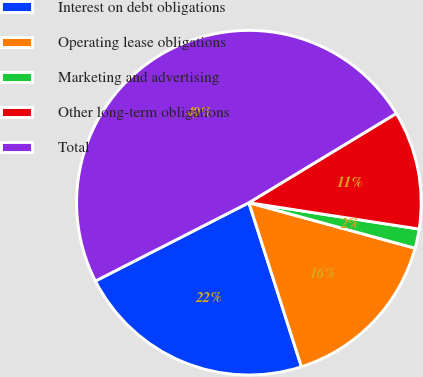Convert chart. <chart><loc_0><loc_0><loc_500><loc_500><pie_chart><fcel>Interest on debt obligations<fcel>Operating lease obligations<fcel>Marketing and advertising<fcel>Other long-term obligations<fcel>Total<nl><fcel>22.42%<fcel>15.81%<fcel>1.81%<fcel>11.11%<fcel>48.84%<nl></chart> 